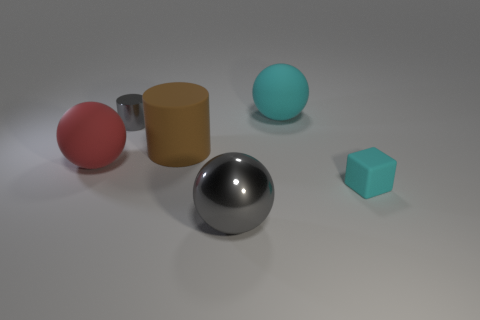Add 2 big gray spheres. How many objects exist? 8 Subtract all big matte spheres. How many spheres are left? 1 Subtract 1 cylinders. How many cylinders are left? 1 Add 2 metal spheres. How many metal spheres are left? 3 Add 4 small cyan rubber things. How many small cyan rubber things exist? 5 Subtract all gray cylinders. How many cylinders are left? 1 Subtract 0 green cubes. How many objects are left? 6 Subtract all cubes. How many objects are left? 5 Subtract all green spheres. Subtract all green cubes. How many spheres are left? 3 Subtract all red cylinders. How many yellow balls are left? 0 